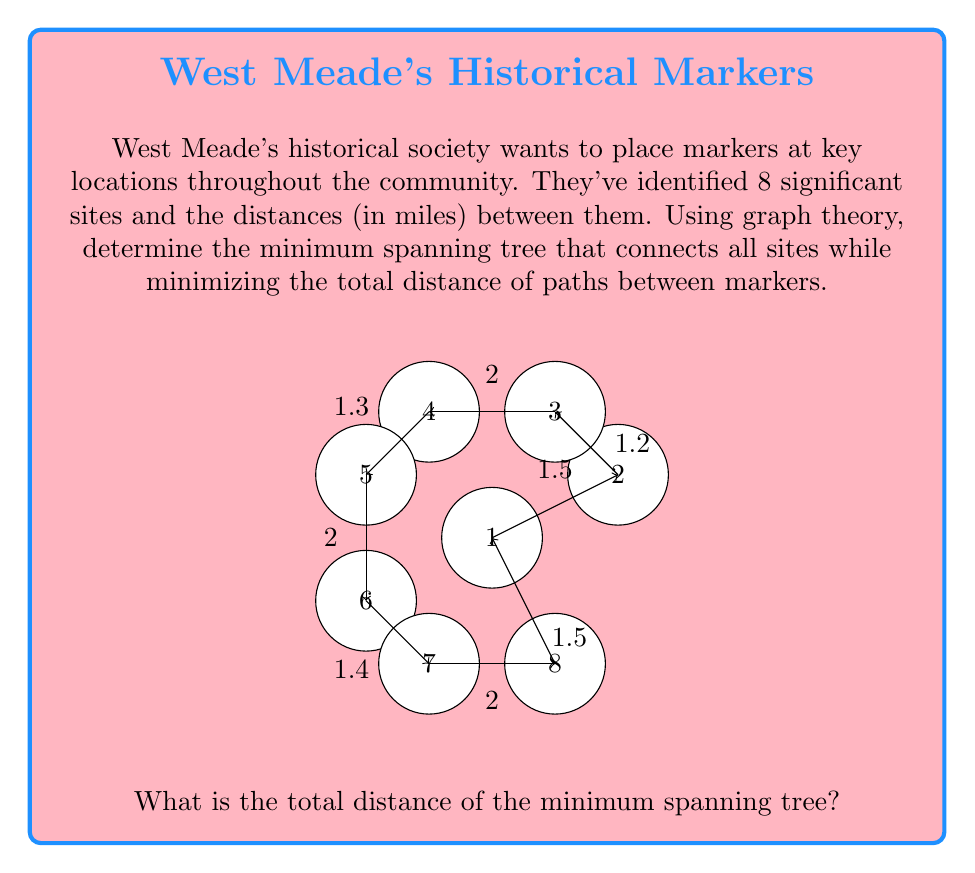Help me with this question. To solve this problem, we'll use Kruskal's algorithm to find the minimum spanning tree:

1) First, list all edges and their weights:
   1-2: 1.5, 2-3: 1.2, 3-4: 2, 4-5: 1.3, 5-6: 2, 6-7: 1.4, 7-8: 2, 8-1: 1.5

2) Sort edges by weight in ascending order:
   2-3: 1.2, 4-5: 1.3, 6-7: 1.4, 1-2: 1.5, 8-1: 1.5, 3-4: 2, 5-6: 2, 7-8: 2

3) Add edges to the spanning tree, skipping any that would create a cycle:
   - Add 2-3 (1.2)
   - Add 4-5 (1.3)
   - Add 6-7 (1.4)
   - Add 1-2 (1.5)
   - Add 8-1 (1.5)
   - Add 3-4 (2)
   - Skip 5-6 (would create cycle)
   - Skip 7-8 (would create cycle)

4) The minimum spanning tree is complete with 7 edges (n-1 where n is the number of vertices).

5) Calculate the total distance:
   $$ \text{Total distance} = 1.2 + 1.3 + 1.4 + 1.5 + 1.5 + 2 = 8.9 \text{ miles} $$

Therefore, the minimum spanning tree has a total distance of 8.9 miles.
Answer: 8.9 miles 